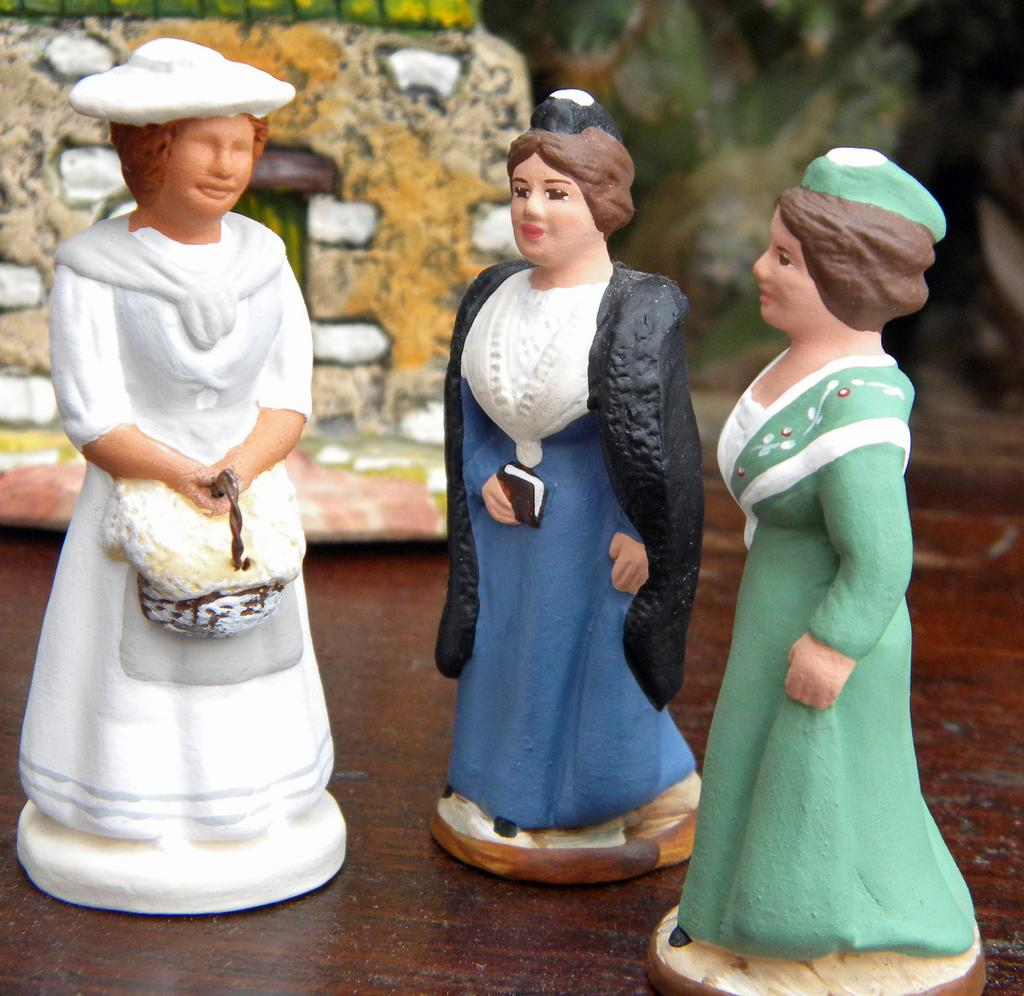What type of objects are in the image? There are three women sculpture dolls in the image. Where are the dolls placed? The dolls are placed on a wooden plank. What can be seen in the background of the image? There is a toy house in the background of the image. What type of plant is growing on the chain in the image? There is no plant or chain present in the image. 